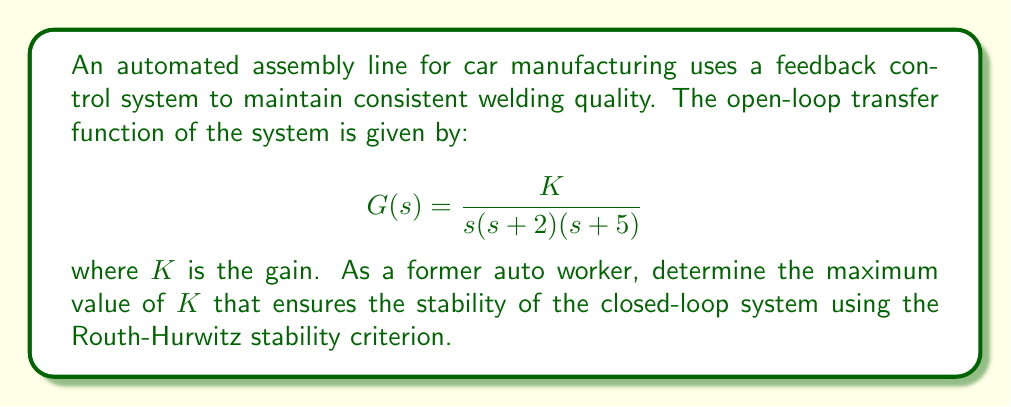Show me your answer to this math problem. To analyze the stability of the closed-loop system, we need to follow these steps:

1) First, we need to determine the characteristic equation of the closed-loop system. The closed-loop transfer function is:

   $$T(s) = \frac{G(s)}{1 + G(s)} = \frac{K}{s(s+2)(s+5) + K}$$

   The characteristic equation is the denominator set to zero:

   $$s(s+2)(s+5) + K = 0$$

2) Expand the characteristic equation:

   $$s^3 + 7s^2 + 10s + K = 0$$

3) Now we can apply the Routh-Hurwitz stability criterion. We start by creating the Routh array:

   $$\begin{array}{c|c}
   s^3 & 1 & 10 \\
   s^2 & 7 & K \\
   s^1 & \frac{70-K}{7} & 0 \\
   s^0 & K & 0
   \end{array}$$

4) For the system to be stable, all elements in the first column of the Routh array must be positive. We already know that 1 and 7 are positive, so we need to ensure:

   $$\frac{70-K}{7} > 0 \quad \text{and} \quad K > 0$$

5) From the first inequality:

   $$70-K > 0$$
   $$-K > -70$$
   $$K < 70$$

6) Combining this with the condition that $K > 0$, we get:

   $$0 < K < 70$$

Therefore, the maximum value of $K$ that ensures stability is just under 70.
Answer: The maximum value of $K$ that ensures stability of the closed-loop system is 70 (exclusive). 